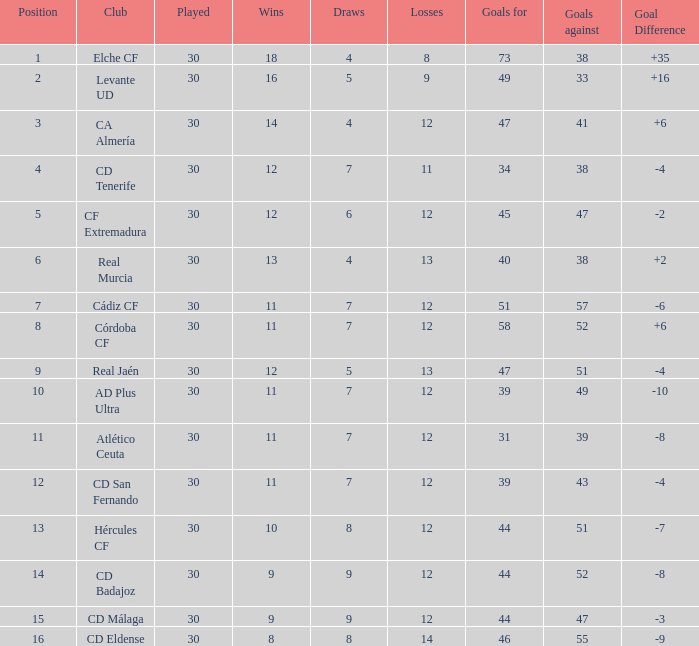What is the average number of goals against with more than 12 wins, 12 losses, and a position greater than 3? None. 